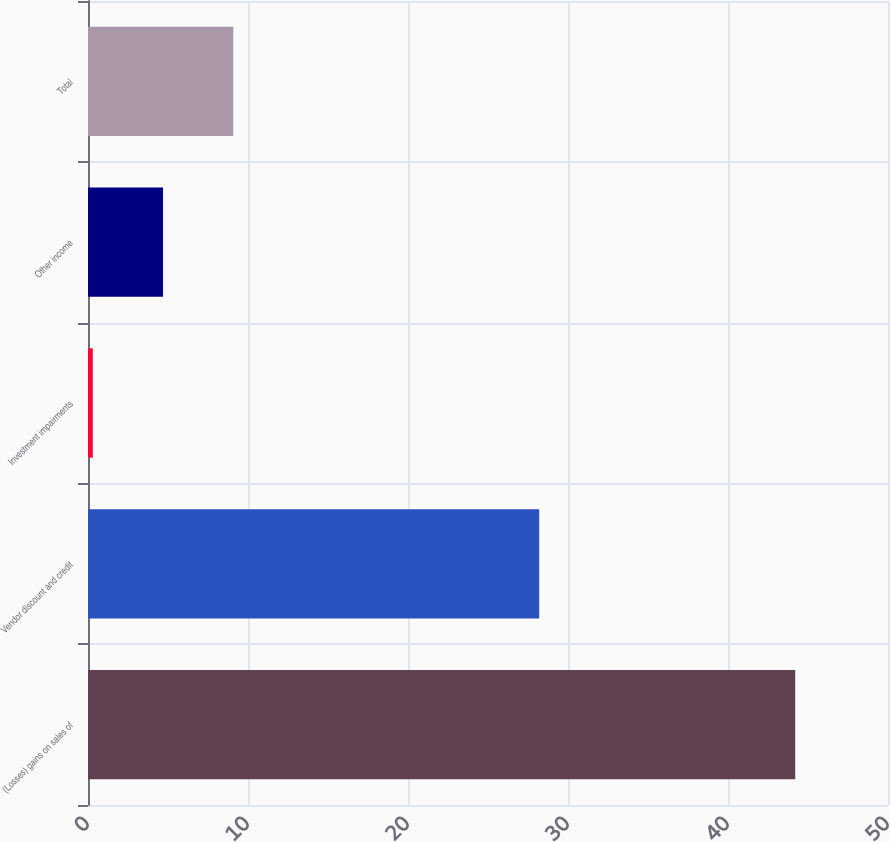<chart> <loc_0><loc_0><loc_500><loc_500><bar_chart><fcel>(Losses) gains on sales of<fcel>Vendor discount and credit<fcel>Investment impairments<fcel>Other income<fcel>Total<nl><fcel>44.2<fcel>28.2<fcel>0.3<fcel>4.69<fcel>9.08<nl></chart> 